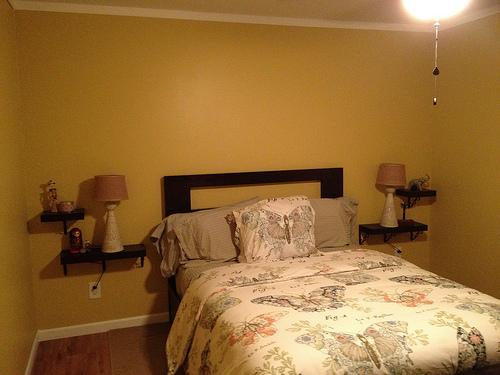What is the pattern on the bedspread and the matching pillowcase? The bedspread and matching pillowcase have a colorful butterfly pattern. Briefly describe the lighting situation in the bedroom. There is a ceiling light turned on, a bedside lamp with a brown shade, and another decorative lamp with a brown shade. Assess the quality of the image in terms of clarity and detail. The image appears to be of high quality, with clear and detailed representations of objects in the bedroom. In your opinion, what emotions could be associated with the interiors and the objects in the room? The bedroom could evoke a feeling of comfort, warmth, and tranquility due to its cozy furnishings and decorations. How would you describe the ambiance of the bedroom? The ambiance of the bedroom is comfortable, quiet, and well-lit with a nice view of various decor elements. Name three decorative items present in the bedroom. Three decorative items are the decorative grey elephant, ruffled pillowcase, and the shelves containing bedside decor. Identify the presence of specific electrical components in the room. There is an electrical outlet under the stand, a cord plugged into the wall outlet, and a switch part visible. Count the number of pillows visible in the image. There are at least seven visible pillows in the image. What is the main piece of furniture in this bedroom scene? The main piece of furniture in the bedroom is a bed with a colorful butterfly bedspread and matching pillows. Analyze the interaction between any two objects in the bedroom. The cord plugged into the wall outlet interacts with the electrical outlet, providing power to the bedside lamp. Can you find the large butterfly print on the pillowcase? The large butterfly print is on the comforter (X:249 Y:283), not on the pillowcase. Which object in the room has an 'on/off' pull cord? The ceiling light What type of object is located on the ceiling of the bedroom? Ceiling light with pull strings What colors are prominent in this bedroom? Yellow, brown, and the colors in the butterfly print. Does the decorative grey elephant have a blue color? The decorative elephant is described as grey (X:407 Y:175) and there is no mention of a blue color. Is the electrical outlet to plug in the lamp located on the ceiling? The electrical outlet is actually located on the wall (X:81 Y:279), not on the ceiling. What is the purpose of the floating shelf? To place and display small objects or decor items Do the four rumpled pillows have a square design on them? The four rumpled pillows (X:148 Y:194) are not described as having a square design. What is the main object with a colorful butterfly design? Bed spread Do the pillows and bedspread have matching butterfly patterns, Yes or No? Yes Is the brown floating shelf hanging from a tree? The brown floating shelf is on the wall (X:47 Y:244) and there is no mention of a tree in the image. What is the predominant shape of the headboard of the bed? Rectangle with a rectangular cut out Name one event that can happen in this bedroom. Getting ready for bed How many pillows can be seen on the bed? Four rumpled pillows Describe the bedspread in the image. Colorful bed spread with a large butterfly print. What are the functions of the butterfly bedspread and pillows in this image? Decoration and comfort What type of wall decoration is present at the top of the bedroom walls? White crown molding Identify an activity that might be occurring in the bedroom. Sleeping or resting Is there a green lampshade on the bedside lamp? The lampshade on the bedside lamp is described as brown (X:83 Y:162), not green. Identify a key object in the room that provides light. Decorate lamp with brown shade What color is the lampshade on the bedside lamp? Brown Is the light source turned on or off in this image? On Which two objects in the image have similar designs and colors? Butterfly bed spread and matching butterfly pillow case Describe the connection between the lamp and the electrical outlet. Cord plugged into wall outlet What is the dominant mood depicted in this bedroom scene? Calm and peaceful How would you describe the small object on the stand next to the bed? Decorative grey elephant 